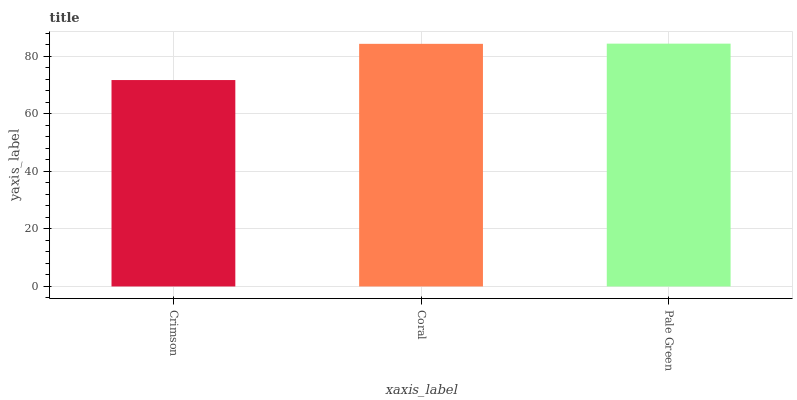Is Crimson the minimum?
Answer yes or no. Yes. Is Pale Green the maximum?
Answer yes or no. Yes. Is Coral the minimum?
Answer yes or no. No. Is Coral the maximum?
Answer yes or no. No. Is Coral greater than Crimson?
Answer yes or no. Yes. Is Crimson less than Coral?
Answer yes or no. Yes. Is Crimson greater than Coral?
Answer yes or no. No. Is Coral less than Crimson?
Answer yes or no. No. Is Coral the high median?
Answer yes or no. Yes. Is Coral the low median?
Answer yes or no. Yes. Is Crimson the high median?
Answer yes or no. No. Is Crimson the low median?
Answer yes or no. No. 